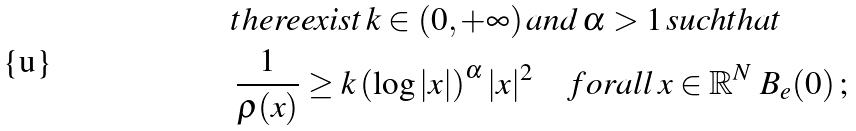<formula> <loc_0><loc_0><loc_500><loc_500>& t h e r e e x i s t \, k \in ( 0 , + \infty ) \, a n d \, \alpha > 1 \, s u c h t h a t \\ & \, \frac { 1 } { \rho ( x ) } \geq k \left ( \log | x | \right ) ^ { \alpha } | x | ^ { 2 } \quad f o r a l l \, x \in \mathbb { R } ^ { N } \ B _ { e } ( 0 ) \, ; \\</formula> 